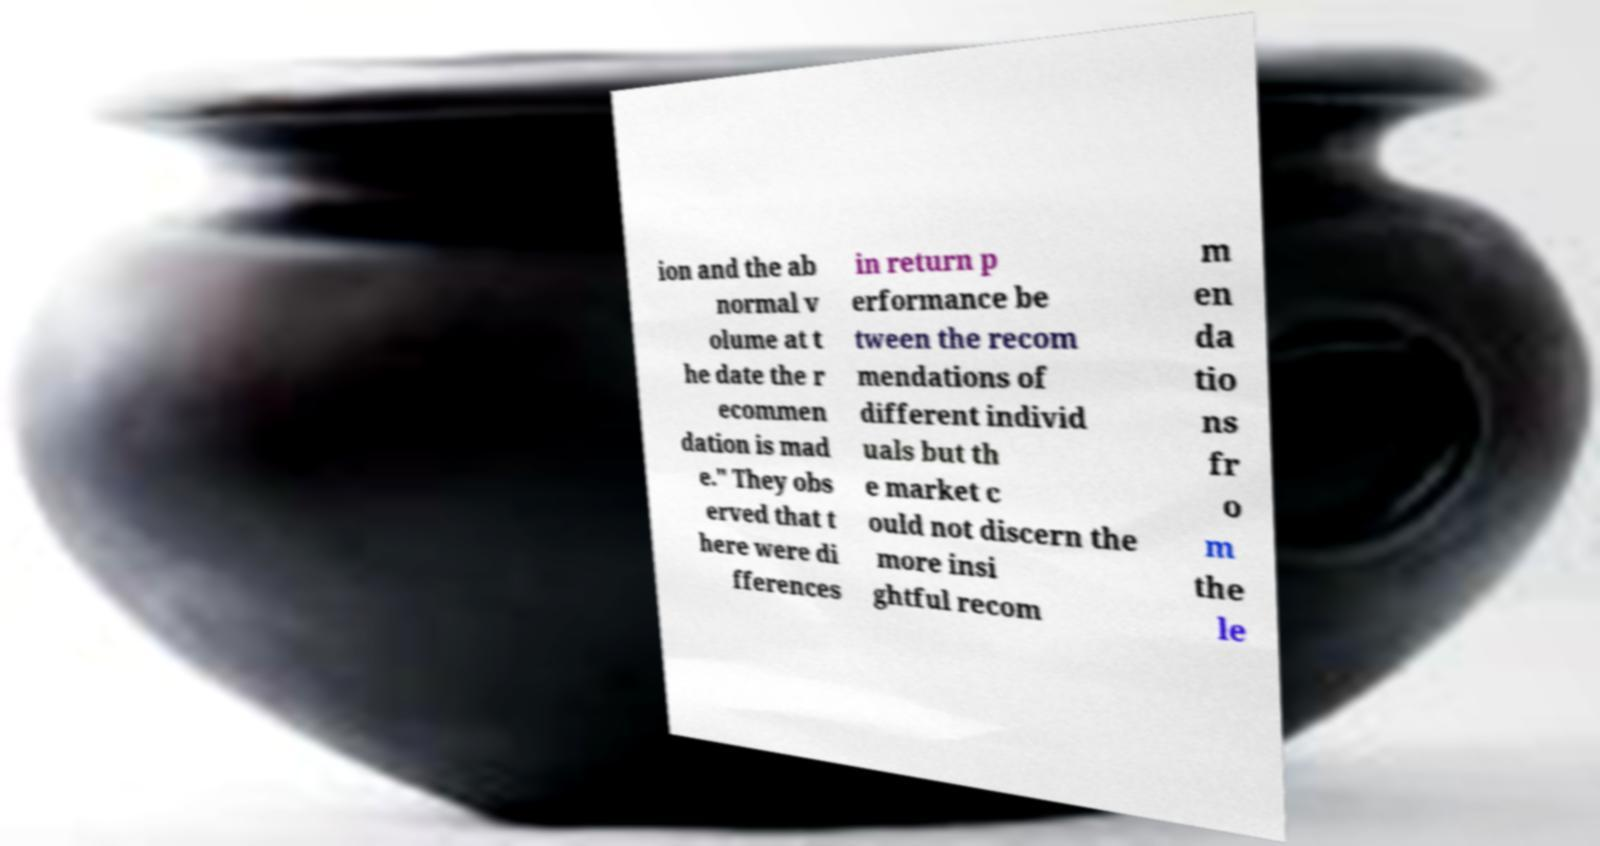Can you read and provide the text displayed in the image?This photo seems to have some interesting text. Can you extract and type it out for me? ion and the ab normal v olume at t he date the r ecommen dation is mad e." They obs erved that t here were di fferences in return p erformance be tween the recom mendations of different individ uals but th e market c ould not discern the more insi ghtful recom m en da tio ns fr o m the le 